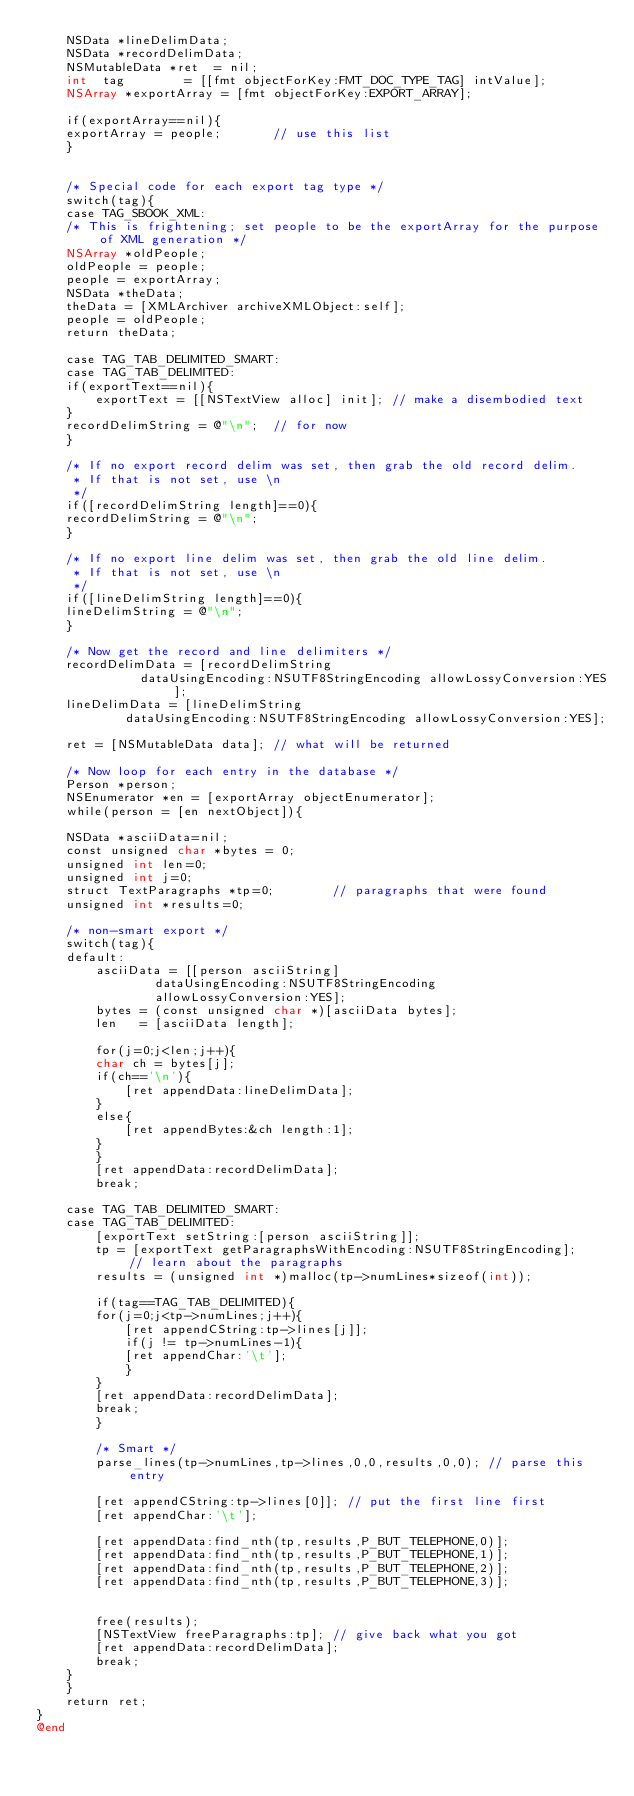<code> <loc_0><loc_0><loc_500><loc_500><_ObjectiveC_>    NSData *lineDelimData;
    NSData *recordDelimData;
    NSMutableData *ret  = nil;
    int  tag		= [[fmt objectForKey:FMT_DOC_TYPE_TAG] intValue];
    NSArray *exportArray = [fmt objectForKey:EXPORT_ARRAY];
    
    if(exportArray==nil){
	exportArray = people;		// use this list
    }


    /* Special code for each export tag type */
    switch(tag){
    case TAG_SBOOK_XML:
	/* This is frightening; set people to be the exportArray for the purpose of XML generation */
	NSArray *oldPeople;
	oldPeople = people;
	people = exportArray;
	NSData *theData;
	theData = [XMLArchiver archiveXMLObject:self];
	people = oldPeople;
	return theData;

    case TAG_TAB_DELIMITED_SMART:
    case TAG_TAB_DELIMITED:    
	if(exportText==nil){
	    exportText = [[NSTextView alloc] init]; // make a disembodied text
	}
	recordDelimString = @"\n";	// for now
    }

    /* If no export record delim was set, then grab the old record delim.
     * If that is not set, use \n
     */
    if([recordDelimString length]==0){
	recordDelimString = @"\n";
    }

    /* If no export line delim was set, then grab the old line delim.
     * If that is not set, use \n
     */
    if([lineDelimString length]==0){
	lineDelimString = @"\n";
    }

    /* Now get the record and line delimiters */
    recordDelimData = [recordDelimString
			  dataUsingEncoding:NSUTF8StringEncoding allowLossyConversion:YES];
    lineDelimData = [lineDelimString
			dataUsingEncoding:NSUTF8StringEncoding allowLossyConversion:YES];

    ret = [NSMutableData data];	// what will be returned

    /* Now loop for each entry in the database */
    Person *person;
    NSEnumerator *en = [exportArray objectEnumerator];
    while(person = [en nextObject]){

	NSData *asciiData=nil;
	const unsigned char *bytes = 0;
	unsigned int len=0;
	unsigned int j=0;
	struct TextParagraphs *tp=0;		// paragraphs that were found
	unsigned int *results=0;

	/* non-smart export */
	switch(tag){
	default:
	    asciiData = [[person asciiString]
			    dataUsingEncoding:NSUTF8StringEncoding
			    allowLossyConversion:YES];
	    bytes = (const unsigned char *)[asciiData bytes];
	    len   = [asciiData length];

	    for(j=0;j<len;j++){
		char ch = bytes[j];
		if(ch=='\n'){
		    [ret appendData:lineDelimData];
		}
		else{
		    [ret appendBytes:&ch length:1];
		}
	    }
	    [ret appendData:recordDelimData];
	    break;

	case TAG_TAB_DELIMITED_SMART:
	case TAG_TAB_DELIMITED:
	    [exportText setString:[person asciiString]];
	    tp = [exportText getParagraphsWithEncoding:NSUTF8StringEncoding];	// learn about the paragraphs
	    results = (unsigned int *)malloc(tp->numLines*sizeof(int));

	    if(tag==TAG_TAB_DELIMITED){
		for(j=0;j<tp->numLines;j++){
		    [ret appendCString:tp->lines[j]];
		    if(j != tp->numLines-1){
			[ret appendChar:'\t'];
		    }
		}
		[ret appendData:recordDelimData];
		break;
	    }

	    /* Smart */
	    parse_lines(tp->numLines,tp->lines,0,0,results,0,0); // parse this entry

	    [ret appendCString:tp->lines[0]]; // put the first line first
	    [ret appendChar:'\t'];

	    [ret appendData:find_nth(tp,results,P_BUT_TELEPHONE,0)];
	    [ret appendData:find_nth(tp,results,P_BUT_TELEPHONE,1)];
	    [ret appendData:find_nth(tp,results,P_BUT_TELEPHONE,2)];
	    [ret appendData:find_nth(tp,results,P_BUT_TELEPHONE,3)];


	    free(results);
	    [NSTextView freeParagraphs:tp];	// give back what you got
	    [ret appendData:recordDelimData];
	    break;
	}
    }
    return ret;
}
@end

 
</code> 